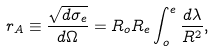Convert formula to latex. <formula><loc_0><loc_0><loc_500><loc_500>r _ { A } \equiv \frac { \sqrt { d \sigma _ { e } } } { d \Omega } = R _ { o } R _ { e } \int _ { o } ^ { e } \frac { d \lambda } { R ^ { 2 } } ,</formula> 